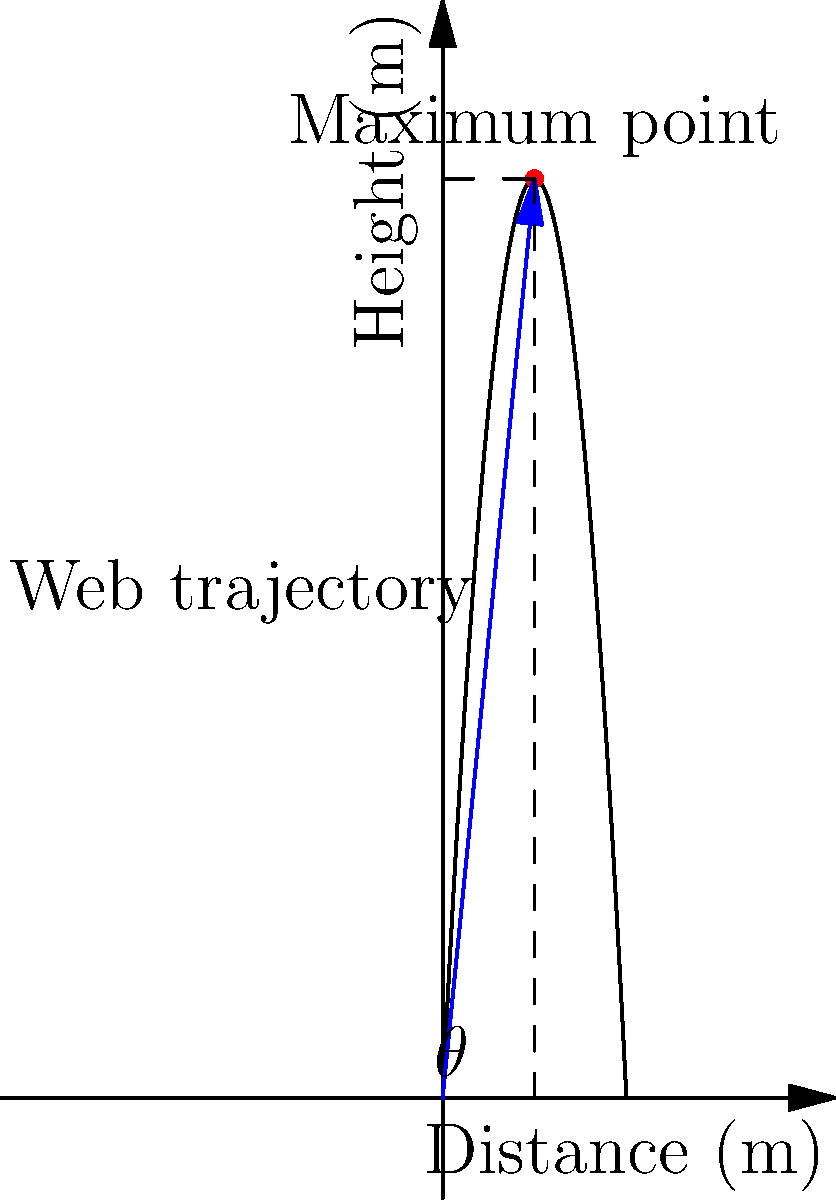Spider-Man is practicing his web-slinging skills and wants to determine the optimal angle to shoot his web for maximum horizontal distance. Assuming the web follows a parabolic trajectory described by the function $h(x) = -0.5x^2 + 20x$, where $h$ is the height in meters and $x$ is the horizontal distance in meters, what is the optimal angle $\theta$ (in degrees) at which Spider-Man should shoot his web to achieve the maximum horizontal distance? To find the optimal angle, we need to follow these steps:

1) First, we need to find the maximum point of the parabola. The vertex of the parabola represents the maximum height and half of the maximum distance.

2) For a quadratic function in the form $f(x) = ax^2 + bx + c$, the x-coordinate of the vertex is given by $x = -\frac{b}{2a}$.

3) In our case, $a = -0.5$ and $b = 20$. So:

   $x = -\frac{20}{2(-0.5)} = 20$

4) This means the maximum horizontal distance is 40 meters, and it occurs at $x = 20$ meters.

5) To find the height at this point, we substitute $x = 20$ into the original equation:

   $h(20) = -0.5(20)^2 + 20(20) = -200 + 400 = 200$

6) Now we have a right triangle with base 20 and height 200.

7) We can find the angle $\theta$ using the tangent function:

   $\tan(\theta) = \frac{\text{opposite}}{\text{adjacent}} = \frac{200}{20} = 10$

8) Therefore, $\theta = \arctan(10)$

9) Converting to degrees: $\theta = \arctan(10) * \frac{180}{\pi} \approx 84.29°$
Answer: $84.29°$ 